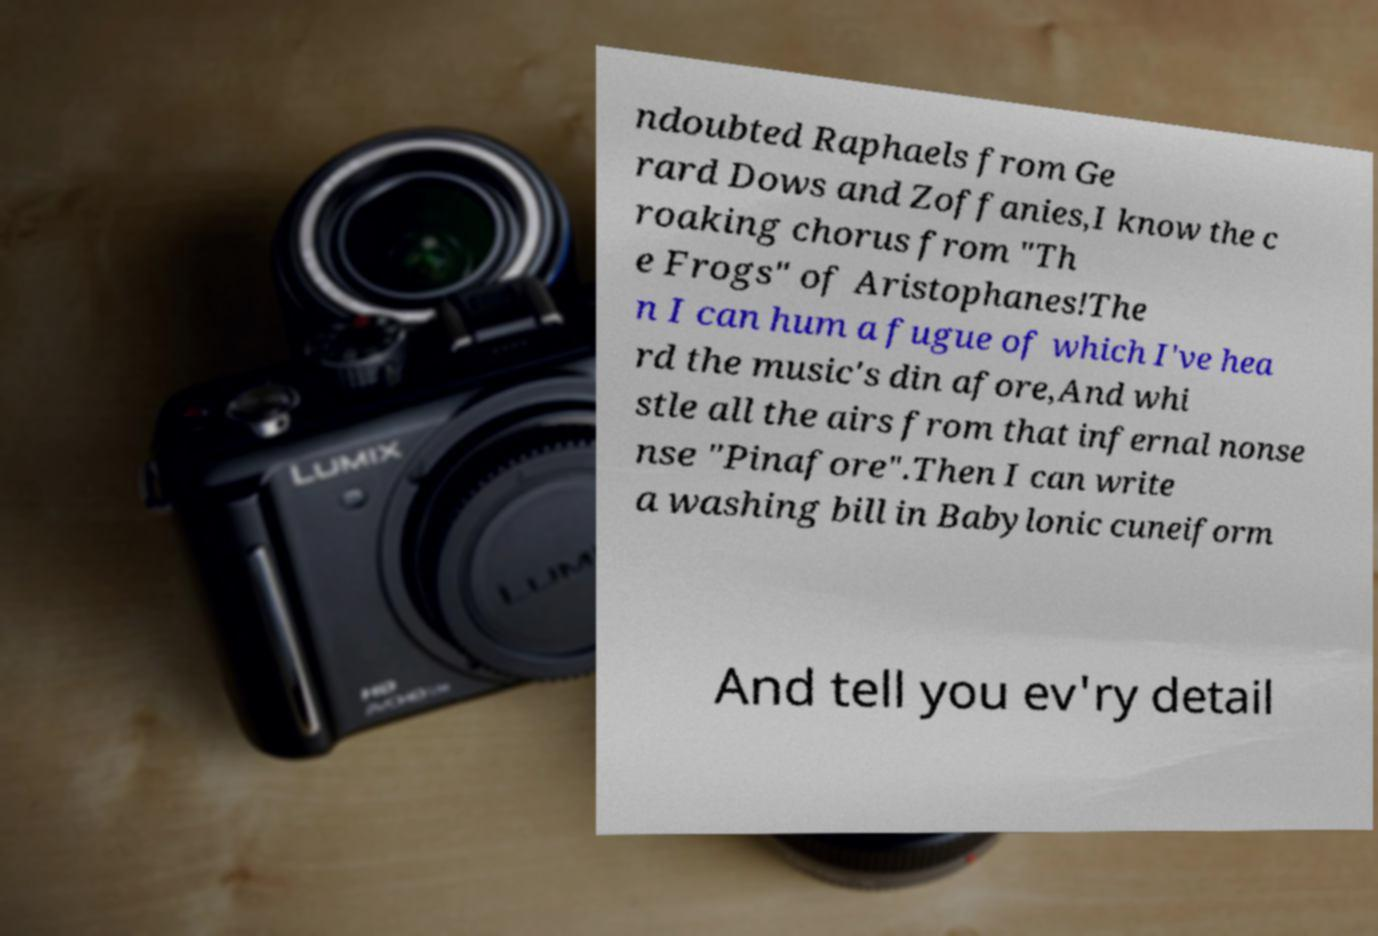What messages or text are displayed in this image? I need them in a readable, typed format. ndoubted Raphaels from Ge rard Dows and Zoffanies,I know the c roaking chorus from "Th e Frogs" of Aristophanes!The n I can hum a fugue of which I've hea rd the music's din afore,And whi stle all the airs from that infernal nonse nse "Pinafore".Then I can write a washing bill in Babylonic cuneiform And tell you ev'ry detail 